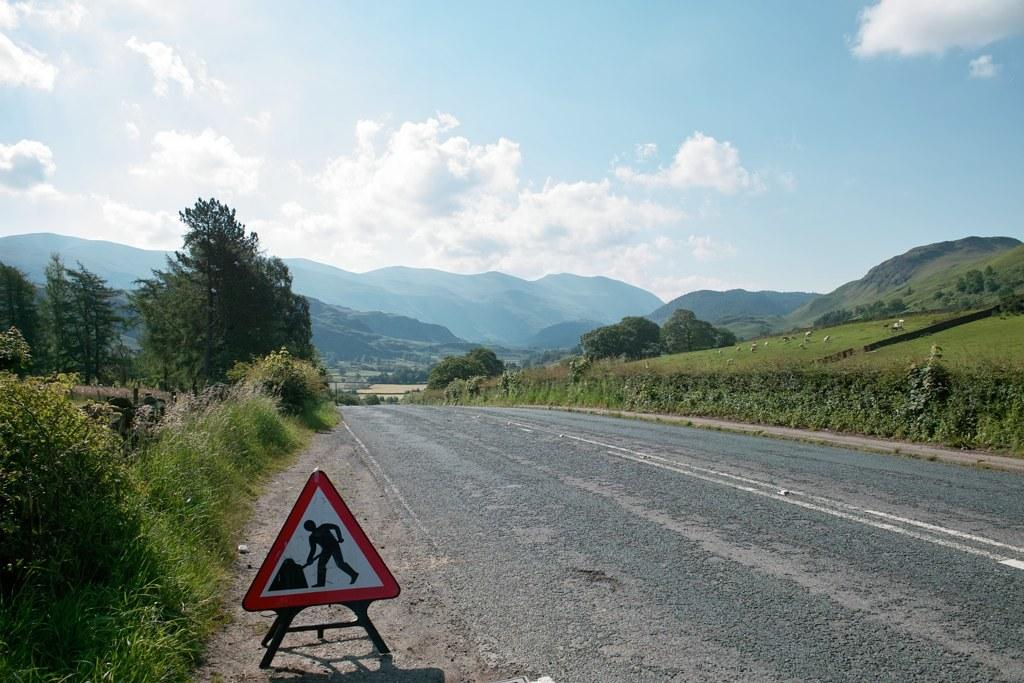What is the main feature of the image? There is a road in the image. What can be seen beside the road? There is grass, crops, and trees beside the road. What is present to provide information or directions? There is an indication board in the image. What can be seen in the background of the image? Hills and the sky are visible in the background. What is the condition of the sky in the image? Clouds are present in the sky. Can you tell me how many people are in the group that is helping to join the trees together in the image? There is no group of people helping to join trees together in the image; it only features a road, grass, crops, trees, an indication board, hills, and the sky. 